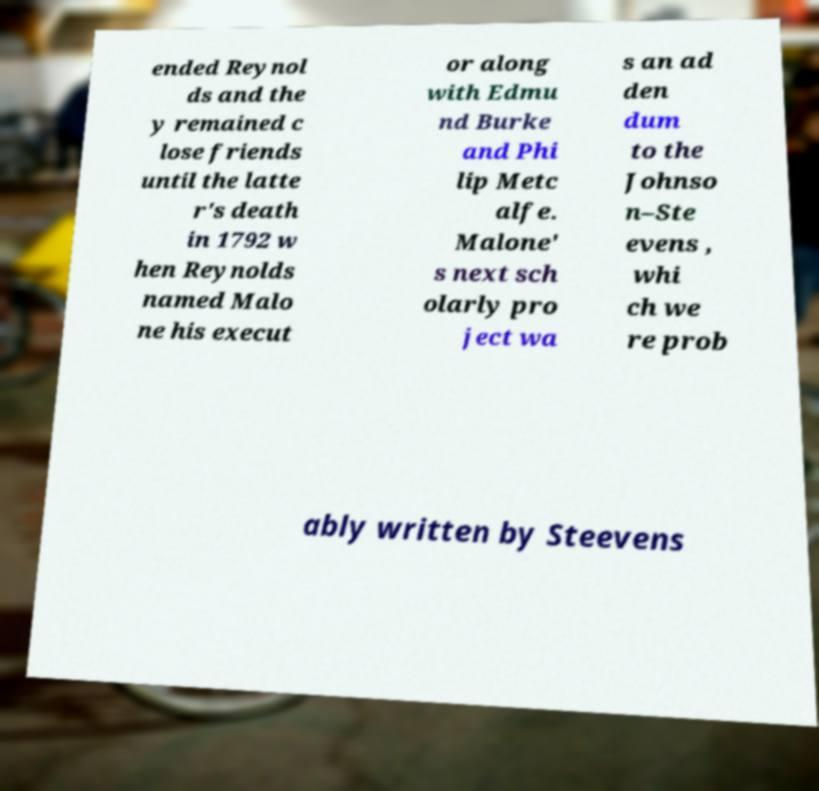Can you read and provide the text displayed in the image?This photo seems to have some interesting text. Can you extract and type it out for me? ended Reynol ds and the y remained c lose friends until the latte r's death in 1792 w hen Reynolds named Malo ne his execut or along with Edmu nd Burke and Phi lip Metc alfe. Malone' s next sch olarly pro ject wa s an ad den dum to the Johnso n–Ste evens , whi ch we re prob ably written by Steevens 